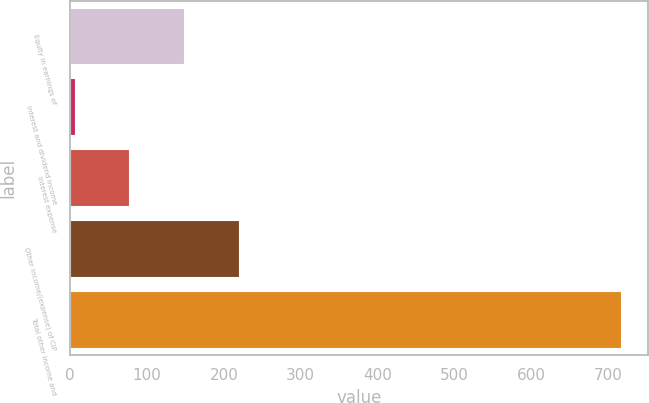<chart> <loc_0><loc_0><loc_500><loc_500><bar_chart><fcel>Equity in earnings of<fcel>Interest and dividend income<fcel>Interest expense<fcel>Other income/(expense) of CIP<fcel>Total other income and<nl><fcel>148.2<fcel>6.2<fcel>77.2<fcel>219.2<fcel>716.2<nl></chart> 